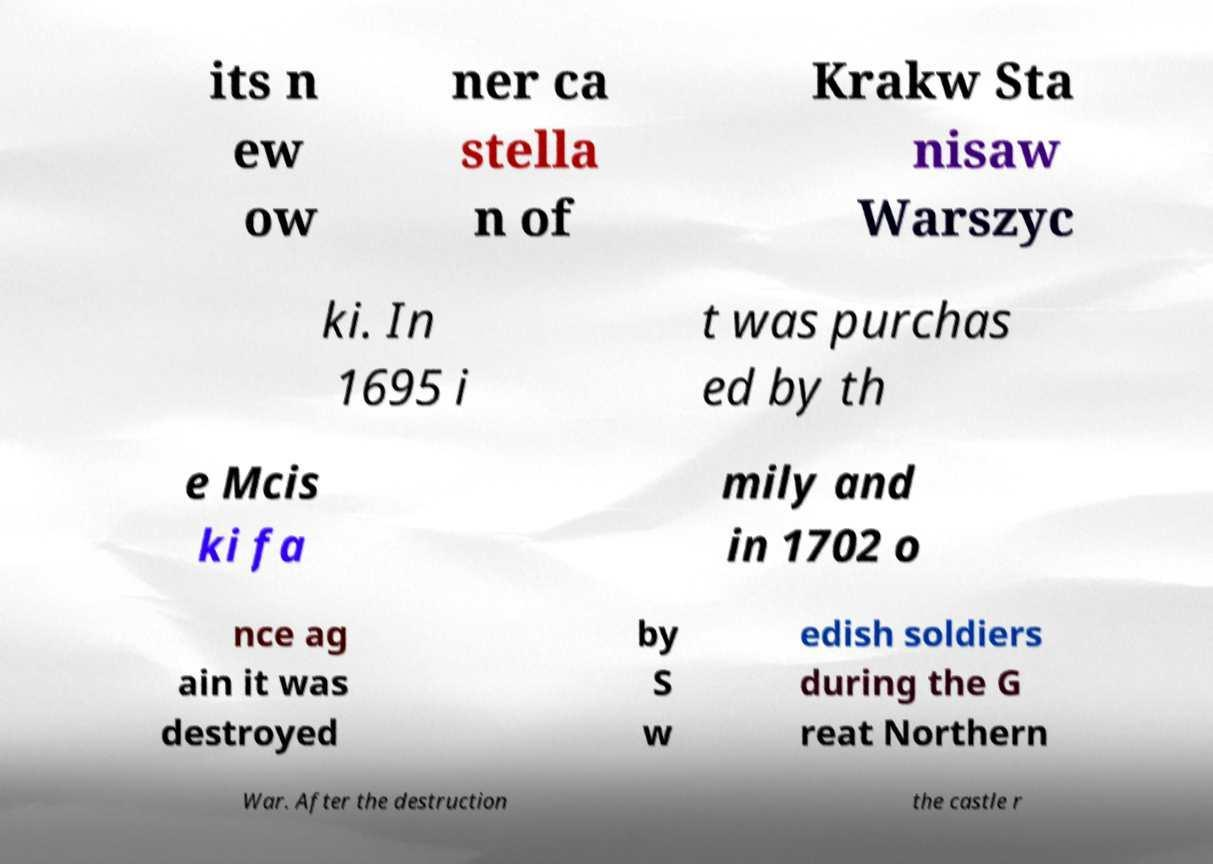Please identify and transcribe the text found in this image. its n ew ow ner ca stella n of Krakw Sta nisaw Warszyc ki. In 1695 i t was purchas ed by th e Mcis ki fa mily and in 1702 o nce ag ain it was destroyed by S w edish soldiers during the G reat Northern War. After the destruction the castle r 